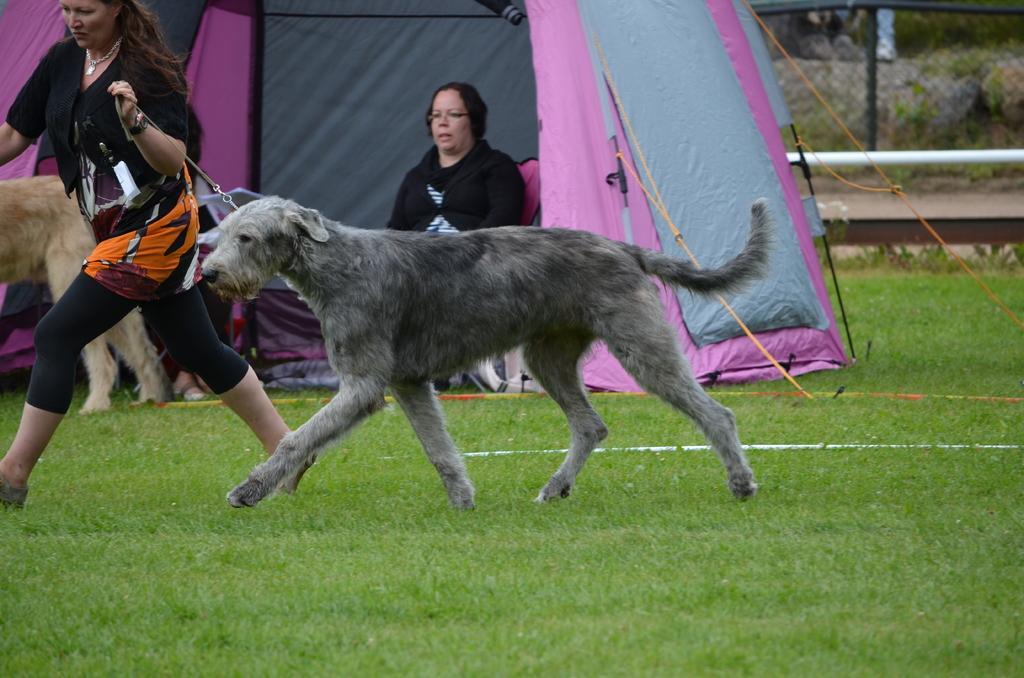Could you give a brief overview of what you see in this image? In this picture we can see woman running along with the dog on grass and in background we can see woman sitting under tent and in fence, rod, ropes to it. 